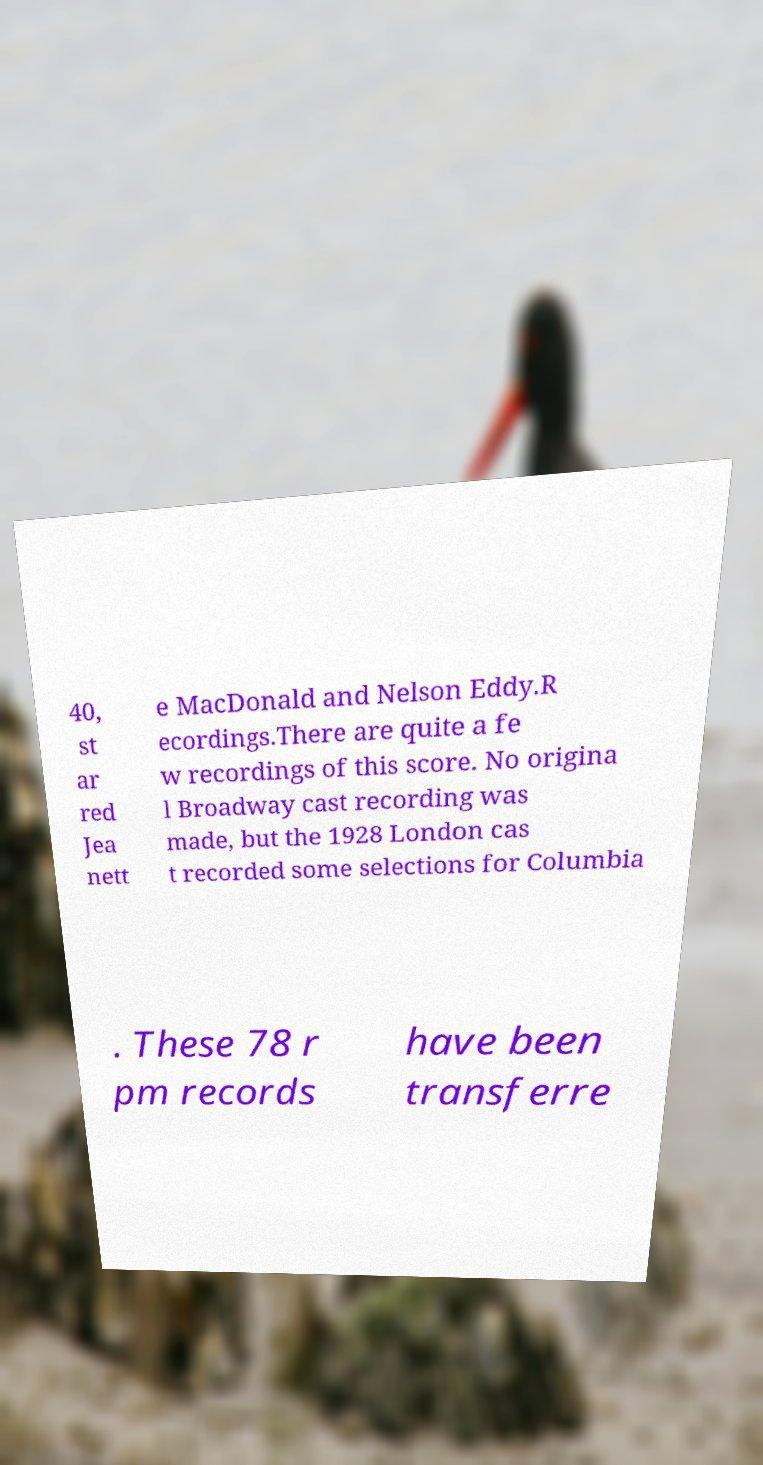Could you assist in decoding the text presented in this image and type it out clearly? 40, st ar red Jea nett e MacDonald and Nelson Eddy.R ecordings.There are quite a fe w recordings of this score. No origina l Broadway cast recording was made, but the 1928 London cas t recorded some selections for Columbia . These 78 r pm records have been transferre 